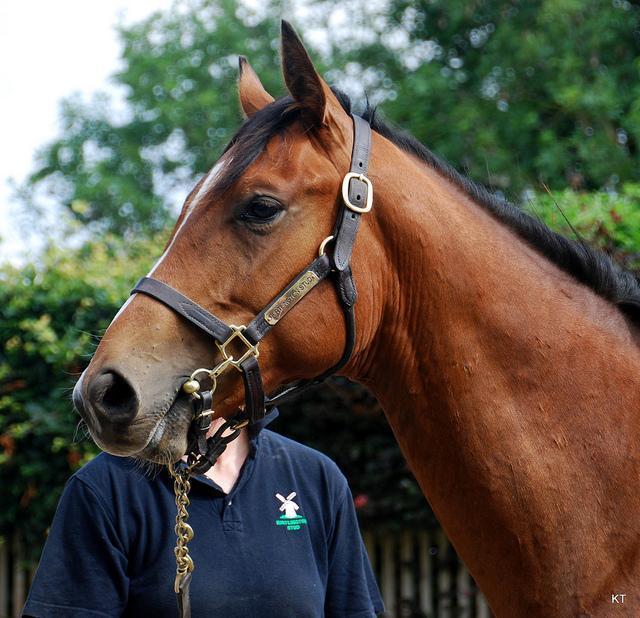How many people's faces do you see?
Give a very brief answer. 0. How many wheels does this truck have?
Give a very brief answer. 0. 